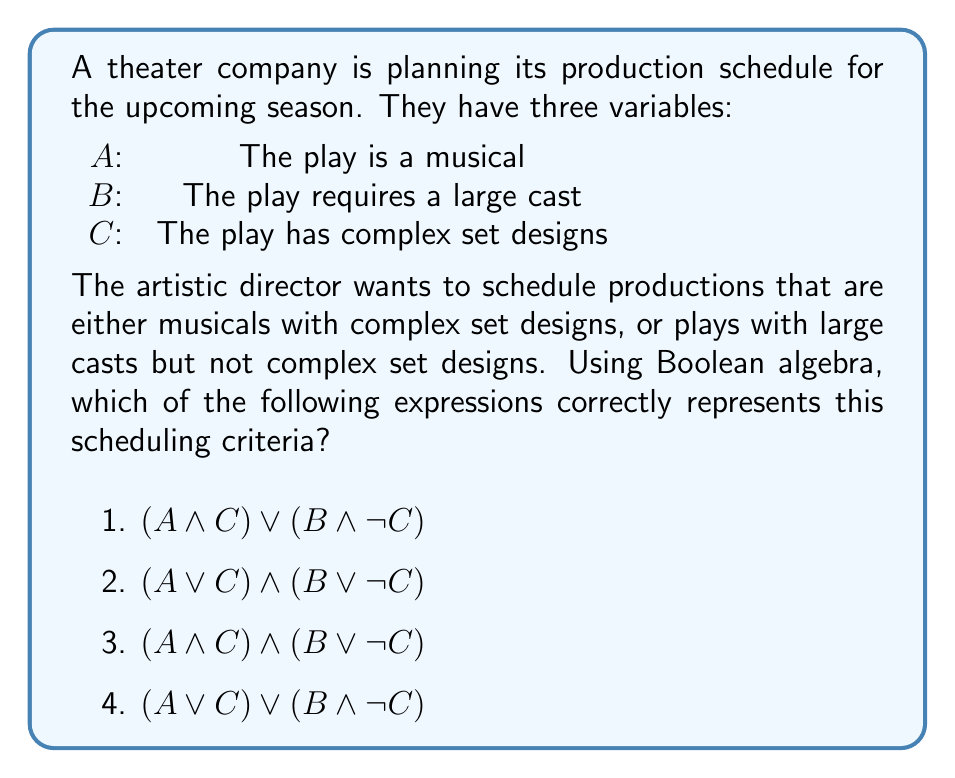Show me your answer to this math problem. Let's break down the artistic director's criteria and translate it into Boolean logic:

1. Musicals with complex set designs: This can be represented as $A \land C$

2. Plays with large casts but not complex set designs: This can be represented as $B \land \lnot C$

3. The director wants either of these conditions to be true: This means we need to use the OR operator ($\lor$) to combine the two conditions.

Therefore, the correct Boolean expression is:

$$(A \land C) \lor (B \land \lnot C)$$

Now, let's evaluate each option:

1) $(A \land C) \lor (B \land \lnot C)$ - This matches our derived expression exactly.

2) $(A \lor C) \land (B \lor \lnot C)$ - This expression doesn't accurately represent the criteria. It would allow for scenarios not intended by the director, such as non-musical plays with complex set designs.

3) $(A \land C) \land (B \lor \lnot C)$ - This expression is too restrictive. It requires all productions to be musicals with complex set designs, which doesn't match the director's criteria.

4) $(A \lor C) \lor (B \land \lnot C)$ - This expression is too permissive. It would allow for any musical or any play with complex set designs, regardless of cast size, which doesn't match the director's criteria.

Therefore, option 1 is the correct answer.
Answer: 1) $(A \land C) \lor (B \land \lnot C)$ 